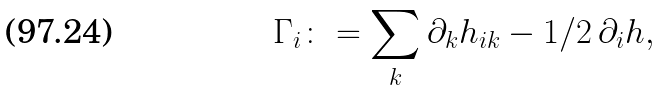<formula> <loc_0><loc_0><loc_500><loc_500>\Gamma _ { i } \colon = \sum _ { k } \partial _ { k } h _ { i k } - 1 / 2 \, \partial _ { i } h ,</formula> 